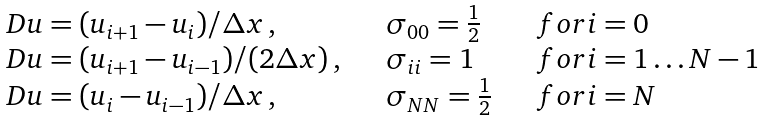Convert formula to latex. <formula><loc_0><loc_0><loc_500><loc_500>\begin{array} { l l l } D u = ( u _ { i + 1 } - u _ { i } ) / \Delta x \, , \quad & \sigma _ { 0 0 } = \frac { 1 } { 2 } \quad & f o r i = 0 \\ D u = ( u _ { i + 1 } - u _ { i - 1 } ) / ( 2 \Delta x ) \, , \quad & \sigma _ { i i } = 1 \quad & f o r i = 1 \dots N - 1 \\ D u = ( u _ { i } - u _ { i - 1 } ) / \Delta x \, , \quad & \sigma _ { N N } = \frac { 1 } { 2 } \quad & f o r i = N \end{array}</formula> 